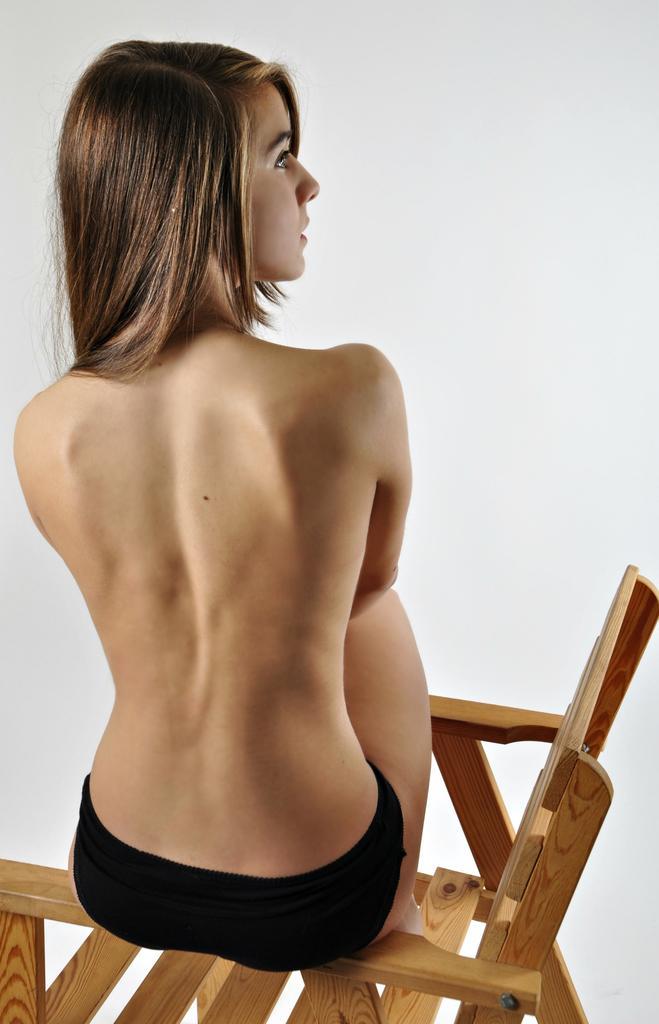Can you describe this image briefly? there is a woman sitting on the wooden chair. 